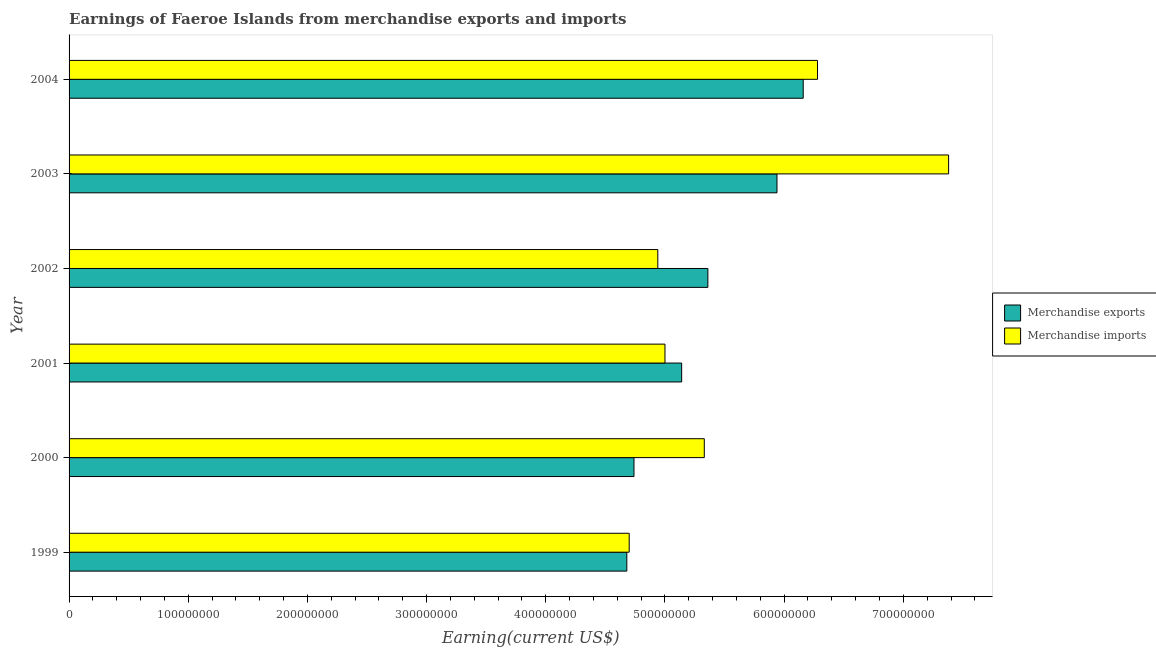How many groups of bars are there?
Keep it short and to the point. 6. How many bars are there on the 5th tick from the top?
Offer a very short reply. 2. How many bars are there on the 1st tick from the bottom?
Ensure brevity in your answer.  2. What is the label of the 4th group of bars from the top?
Offer a very short reply. 2001. In how many cases, is the number of bars for a given year not equal to the number of legend labels?
Your answer should be very brief. 0. What is the earnings from merchandise exports in 2000?
Your response must be concise. 4.74e+08. Across all years, what is the maximum earnings from merchandise exports?
Provide a short and direct response. 6.16e+08. Across all years, what is the minimum earnings from merchandise imports?
Your response must be concise. 4.70e+08. What is the total earnings from merchandise imports in the graph?
Your answer should be very brief. 3.36e+09. What is the difference between the earnings from merchandise exports in 2000 and that in 2003?
Your response must be concise. -1.20e+08. What is the difference between the earnings from merchandise imports in 2004 and the earnings from merchandise exports in 2003?
Provide a succinct answer. 3.40e+07. What is the average earnings from merchandise imports per year?
Offer a terse response. 5.60e+08. In the year 2000, what is the difference between the earnings from merchandise imports and earnings from merchandise exports?
Give a very brief answer. 5.90e+07. In how many years, is the earnings from merchandise exports greater than 680000000 US$?
Your answer should be compact. 0. What is the ratio of the earnings from merchandise exports in 2001 to that in 2002?
Your answer should be very brief. 0.96. Is the difference between the earnings from merchandise exports in 1999 and 2002 greater than the difference between the earnings from merchandise imports in 1999 and 2002?
Your response must be concise. No. What is the difference between the highest and the second highest earnings from merchandise imports?
Offer a very short reply. 1.10e+08. What is the difference between the highest and the lowest earnings from merchandise imports?
Offer a very short reply. 2.68e+08. In how many years, is the earnings from merchandise exports greater than the average earnings from merchandise exports taken over all years?
Provide a short and direct response. 3. Is the sum of the earnings from merchandise exports in 2001 and 2004 greater than the maximum earnings from merchandise imports across all years?
Make the answer very short. Yes. What does the 2nd bar from the top in 2004 represents?
Your answer should be compact. Merchandise exports. What does the 1st bar from the bottom in 2002 represents?
Your answer should be very brief. Merchandise exports. How many bars are there?
Offer a very short reply. 12. Are all the bars in the graph horizontal?
Offer a terse response. Yes. Does the graph contain any zero values?
Your answer should be very brief. No. How are the legend labels stacked?
Your response must be concise. Vertical. What is the title of the graph?
Your answer should be very brief. Earnings of Faeroe Islands from merchandise exports and imports. What is the label or title of the X-axis?
Make the answer very short. Earning(current US$). What is the Earning(current US$) in Merchandise exports in 1999?
Your answer should be compact. 4.68e+08. What is the Earning(current US$) of Merchandise imports in 1999?
Your answer should be compact. 4.70e+08. What is the Earning(current US$) of Merchandise exports in 2000?
Ensure brevity in your answer.  4.74e+08. What is the Earning(current US$) of Merchandise imports in 2000?
Keep it short and to the point. 5.33e+08. What is the Earning(current US$) of Merchandise exports in 2001?
Provide a succinct answer. 5.14e+08. What is the Earning(current US$) of Merchandise imports in 2001?
Your answer should be compact. 5.00e+08. What is the Earning(current US$) of Merchandise exports in 2002?
Your response must be concise. 5.36e+08. What is the Earning(current US$) in Merchandise imports in 2002?
Your response must be concise. 4.94e+08. What is the Earning(current US$) of Merchandise exports in 2003?
Ensure brevity in your answer.  5.94e+08. What is the Earning(current US$) of Merchandise imports in 2003?
Your answer should be compact. 7.38e+08. What is the Earning(current US$) in Merchandise exports in 2004?
Keep it short and to the point. 6.16e+08. What is the Earning(current US$) of Merchandise imports in 2004?
Provide a short and direct response. 6.28e+08. Across all years, what is the maximum Earning(current US$) in Merchandise exports?
Offer a very short reply. 6.16e+08. Across all years, what is the maximum Earning(current US$) in Merchandise imports?
Ensure brevity in your answer.  7.38e+08. Across all years, what is the minimum Earning(current US$) in Merchandise exports?
Your answer should be compact. 4.68e+08. Across all years, what is the minimum Earning(current US$) in Merchandise imports?
Provide a succinct answer. 4.70e+08. What is the total Earning(current US$) in Merchandise exports in the graph?
Keep it short and to the point. 3.20e+09. What is the total Earning(current US$) of Merchandise imports in the graph?
Your response must be concise. 3.36e+09. What is the difference between the Earning(current US$) in Merchandise exports in 1999 and that in 2000?
Your response must be concise. -6.00e+06. What is the difference between the Earning(current US$) of Merchandise imports in 1999 and that in 2000?
Your answer should be very brief. -6.30e+07. What is the difference between the Earning(current US$) of Merchandise exports in 1999 and that in 2001?
Offer a terse response. -4.60e+07. What is the difference between the Earning(current US$) of Merchandise imports in 1999 and that in 2001?
Offer a terse response. -3.00e+07. What is the difference between the Earning(current US$) in Merchandise exports in 1999 and that in 2002?
Ensure brevity in your answer.  -6.80e+07. What is the difference between the Earning(current US$) of Merchandise imports in 1999 and that in 2002?
Ensure brevity in your answer.  -2.40e+07. What is the difference between the Earning(current US$) of Merchandise exports in 1999 and that in 2003?
Give a very brief answer. -1.26e+08. What is the difference between the Earning(current US$) of Merchandise imports in 1999 and that in 2003?
Give a very brief answer. -2.68e+08. What is the difference between the Earning(current US$) in Merchandise exports in 1999 and that in 2004?
Your answer should be compact. -1.48e+08. What is the difference between the Earning(current US$) of Merchandise imports in 1999 and that in 2004?
Ensure brevity in your answer.  -1.58e+08. What is the difference between the Earning(current US$) in Merchandise exports in 2000 and that in 2001?
Keep it short and to the point. -4.00e+07. What is the difference between the Earning(current US$) in Merchandise imports in 2000 and that in 2001?
Provide a short and direct response. 3.30e+07. What is the difference between the Earning(current US$) in Merchandise exports in 2000 and that in 2002?
Provide a short and direct response. -6.20e+07. What is the difference between the Earning(current US$) in Merchandise imports in 2000 and that in 2002?
Ensure brevity in your answer.  3.90e+07. What is the difference between the Earning(current US$) in Merchandise exports in 2000 and that in 2003?
Keep it short and to the point. -1.20e+08. What is the difference between the Earning(current US$) in Merchandise imports in 2000 and that in 2003?
Offer a terse response. -2.05e+08. What is the difference between the Earning(current US$) of Merchandise exports in 2000 and that in 2004?
Your response must be concise. -1.42e+08. What is the difference between the Earning(current US$) of Merchandise imports in 2000 and that in 2004?
Your answer should be compact. -9.50e+07. What is the difference between the Earning(current US$) in Merchandise exports in 2001 and that in 2002?
Ensure brevity in your answer.  -2.20e+07. What is the difference between the Earning(current US$) of Merchandise exports in 2001 and that in 2003?
Provide a short and direct response. -8.00e+07. What is the difference between the Earning(current US$) of Merchandise imports in 2001 and that in 2003?
Ensure brevity in your answer.  -2.38e+08. What is the difference between the Earning(current US$) of Merchandise exports in 2001 and that in 2004?
Provide a succinct answer. -1.02e+08. What is the difference between the Earning(current US$) of Merchandise imports in 2001 and that in 2004?
Make the answer very short. -1.28e+08. What is the difference between the Earning(current US$) in Merchandise exports in 2002 and that in 2003?
Your answer should be compact. -5.80e+07. What is the difference between the Earning(current US$) of Merchandise imports in 2002 and that in 2003?
Offer a very short reply. -2.44e+08. What is the difference between the Earning(current US$) in Merchandise exports in 2002 and that in 2004?
Keep it short and to the point. -8.00e+07. What is the difference between the Earning(current US$) in Merchandise imports in 2002 and that in 2004?
Offer a very short reply. -1.34e+08. What is the difference between the Earning(current US$) of Merchandise exports in 2003 and that in 2004?
Your answer should be compact. -2.20e+07. What is the difference between the Earning(current US$) of Merchandise imports in 2003 and that in 2004?
Your answer should be compact. 1.10e+08. What is the difference between the Earning(current US$) in Merchandise exports in 1999 and the Earning(current US$) in Merchandise imports in 2000?
Provide a succinct answer. -6.50e+07. What is the difference between the Earning(current US$) of Merchandise exports in 1999 and the Earning(current US$) of Merchandise imports in 2001?
Your answer should be compact. -3.20e+07. What is the difference between the Earning(current US$) of Merchandise exports in 1999 and the Earning(current US$) of Merchandise imports in 2002?
Offer a very short reply. -2.60e+07. What is the difference between the Earning(current US$) in Merchandise exports in 1999 and the Earning(current US$) in Merchandise imports in 2003?
Your answer should be very brief. -2.70e+08. What is the difference between the Earning(current US$) of Merchandise exports in 1999 and the Earning(current US$) of Merchandise imports in 2004?
Give a very brief answer. -1.60e+08. What is the difference between the Earning(current US$) of Merchandise exports in 2000 and the Earning(current US$) of Merchandise imports in 2001?
Keep it short and to the point. -2.60e+07. What is the difference between the Earning(current US$) of Merchandise exports in 2000 and the Earning(current US$) of Merchandise imports in 2002?
Keep it short and to the point. -2.00e+07. What is the difference between the Earning(current US$) in Merchandise exports in 2000 and the Earning(current US$) in Merchandise imports in 2003?
Keep it short and to the point. -2.64e+08. What is the difference between the Earning(current US$) in Merchandise exports in 2000 and the Earning(current US$) in Merchandise imports in 2004?
Offer a terse response. -1.54e+08. What is the difference between the Earning(current US$) of Merchandise exports in 2001 and the Earning(current US$) of Merchandise imports in 2002?
Your response must be concise. 2.00e+07. What is the difference between the Earning(current US$) of Merchandise exports in 2001 and the Earning(current US$) of Merchandise imports in 2003?
Offer a very short reply. -2.24e+08. What is the difference between the Earning(current US$) of Merchandise exports in 2001 and the Earning(current US$) of Merchandise imports in 2004?
Your response must be concise. -1.14e+08. What is the difference between the Earning(current US$) of Merchandise exports in 2002 and the Earning(current US$) of Merchandise imports in 2003?
Provide a short and direct response. -2.02e+08. What is the difference between the Earning(current US$) of Merchandise exports in 2002 and the Earning(current US$) of Merchandise imports in 2004?
Your answer should be very brief. -9.20e+07. What is the difference between the Earning(current US$) in Merchandise exports in 2003 and the Earning(current US$) in Merchandise imports in 2004?
Keep it short and to the point. -3.40e+07. What is the average Earning(current US$) in Merchandise exports per year?
Your answer should be compact. 5.34e+08. What is the average Earning(current US$) in Merchandise imports per year?
Your answer should be very brief. 5.60e+08. In the year 2000, what is the difference between the Earning(current US$) in Merchandise exports and Earning(current US$) in Merchandise imports?
Keep it short and to the point. -5.90e+07. In the year 2001, what is the difference between the Earning(current US$) in Merchandise exports and Earning(current US$) in Merchandise imports?
Your answer should be very brief. 1.40e+07. In the year 2002, what is the difference between the Earning(current US$) in Merchandise exports and Earning(current US$) in Merchandise imports?
Your response must be concise. 4.20e+07. In the year 2003, what is the difference between the Earning(current US$) of Merchandise exports and Earning(current US$) of Merchandise imports?
Ensure brevity in your answer.  -1.44e+08. In the year 2004, what is the difference between the Earning(current US$) of Merchandise exports and Earning(current US$) of Merchandise imports?
Provide a succinct answer. -1.20e+07. What is the ratio of the Earning(current US$) in Merchandise exports in 1999 to that in 2000?
Provide a succinct answer. 0.99. What is the ratio of the Earning(current US$) in Merchandise imports in 1999 to that in 2000?
Ensure brevity in your answer.  0.88. What is the ratio of the Earning(current US$) in Merchandise exports in 1999 to that in 2001?
Your answer should be very brief. 0.91. What is the ratio of the Earning(current US$) of Merchandise imports in 1999 to that in 2001?
Offer a terse response. 0.94. What is the ratio of the Earning(current US$) of Merchandise exports in 1999 to that in 2002?
Make the answer very short. 0.87. What is the ratio of the Earning(current US$) in Merchandise imports in 1999 to that in 2002?
Provide a short and direct response. 0.95. What is the ratio of the Earning(current US$) of Merchandise exports in 1999 to that in 2003?
Provide a succinct answer. 0.79. What is the ratio of the Earning(current US$) in Merchandise imports in 1999 to that in 2003?
Provide a succinct answer. 0.64. What is the ratio of the Earning(current US$) in Merchandise exports in 1999 to that in 2004?
Offer a very short reply. 0.76. What is the ratio of the Earning(current US$) of Merchandise imports in 1999 to that in 2004?
Your answer should be very brief. 0.75. What is the ratio of the Earning(current US$) in Merchandise exports in 2000 to that in 2001?
Your answer should be compact. 0.92. What is the ratio of the Earning(current US$) in Merchandise imports in 2000 to that in 2001?
Provide a succinct answer. 1.07. What is the ratio of the Earning(current US$) of Merchandise exports in 2000 to that in 2002?
Offer a terse response. 0.88. What is the ratio of the Earning(current US$) in Merchandise imports in 2000 to that in 2002?
Provide a succinct answer. 1.08. What is the ratio of the Earning(current US$) of Merchandise exports in 2000 to that in 2003?
Your answer should be very brief. 0.8. What is the ratio of the Earning(current US$) of Merchandise imports in 2000 to that in 2003?
Your answer should be very brief. 0.72. What is the ratio of the Earning(current US$) of Merchandise exports in 2000 to that in 2004?
Your answer should be compact. 0.77. What is the ratio of the Earning(current US$) of Merchandise imports in 2000 to that in 2004?
Your response must be concise. 0.85. What is the ratio of the Earning(current US$) in Merchandise exports in 2001 to that in 2002?
Offer a terse response. 0.96. What is the ratio of the Earning(current US$) of Merchandise imports in 2001 to that in 2002?
Your answer should be very brief. 1.01. What is the ratio of the Earning(current US$) in Merchandise exports in 2001 to that in 2003?
Your response must be concise. 0.87. What is the ratio of the Earning(current US$) of Merchandise imports in 2001 to that in 2003?
Provide a short and direct response. 0.68. What is the ratio of the Earning(current US$) in Merchandise exports in 2001 to that in 2004?
Keep it short and to the point. 0.83. What is the ratio of the Earning(current US$) of Merchandise imports in 2001 to that in 2004?
Keep it short and to the point. 0.8. What is the ratio of the Earning(current US$) in Merchandise exports in 2002 to that in 2003?
Your response must be concise. 0.9. What is the ratio of the Earning(current US$) of Merchandise imports in 2002 to that in 2003?
Give a very brief answer. 0.67. What is the ratio of the Earning(current US$) in Merchandise exports in 2002 to that in 2004?
Keep it short and to the point. 0.87. What is the ratio of the Earning(current US$) of Merchandise imports in 2002 to that in 2004?
Give a very brief answer. 0.79. What is the ratio of the Earning(current US$) in Merchandise imports in 2003 to that in 2004?
Offer a terse response. 1.18. What is the difference between the highest and the second highest Earning(current US$) in Merchandise exports?
Offer a very short reply. 2.20e+07. What is the difference between the highest and the second highest Earning(current US$) in Merchandise imports?
Offer a very short reply. 1.10e+08. What is the difference between the highest and the lowest Earning(current US$) in Merchandise exports?
Ensure brevity in your answer.  1.48e+08. What is the difference between the highest and the lowest Earning(current US$) in Merchandise imports?
Provide a short and direct response. 2.68e+08. 